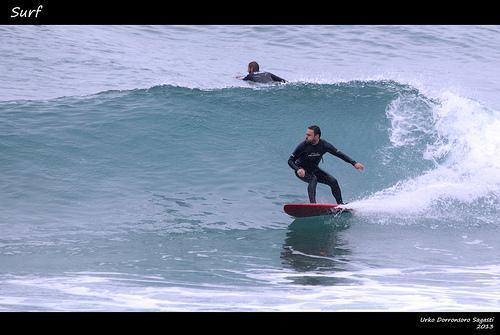How many people are in this photo?
Give a very brief answer. 2. 